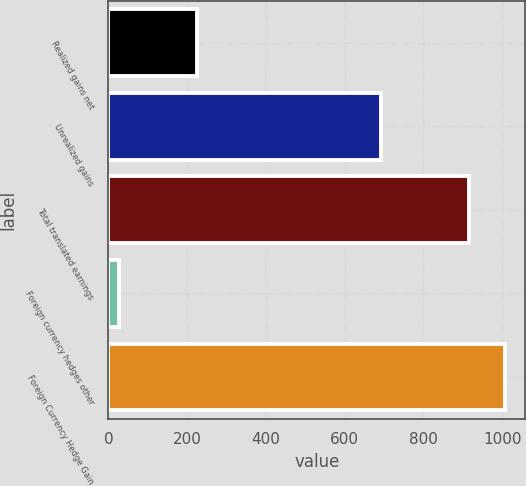Convert chart to OTSL. <chart><loc_0><loc_0><loc_500><loc_500><bar_chart><fcel>Realized gains net<fcel>Unrealized gains<fcel>Total translated earnings<fcel>Foreign currency hedges other<fcel>Foreign Currency Hedge Gain<nl><fcel>224<fcel>692<fcel>916<fcel>27<fcel>1007.6<nl></chart> 